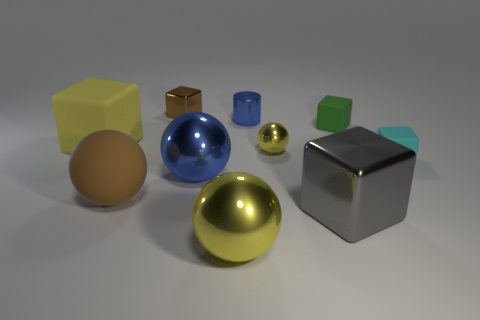There is a brown metallic cube; is its size the same as the yellow metal object that is in front of the blue shiny ball?
Offer a terse response. No. The blue shiny object in front of the yellow matte thing has what shape?
Your answer should be very brief. Sphere. Is there anything else that is the same shape as the gray thing?
Offer a terse response. Yes. Is there a tiny yellow matte ball?
Give a very brief answer. No. There is a brown object that is behind the yellow rubber block; does it have the same size as the yellow metallic thing that is behind the big metal block?
Provide a succinct answer. Yes. What is the object that is left of the big gray metallic thing and in front of the brown sphere made of?
Provide a succinct answer. Metal. How many large blue balls are on the left side of the large brown thing?
Give a very brief answer. 0. Is there anything else that has the same size as the green cube?
Offer a very short reply. Yes. What color is the big cube that is the same material as the large brown thing?
Offer a terse response. Yellow. Is the tiny green matte object the same shape as the small yellow metal object?
Your response must be concise. No. 